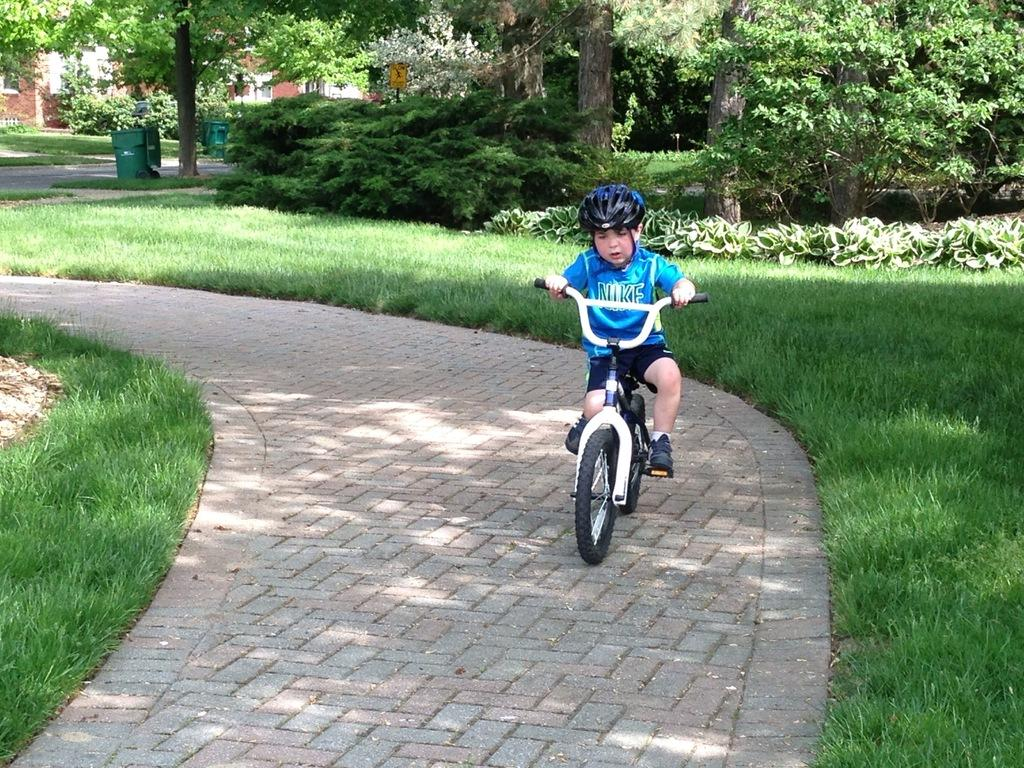What is the kid doing in the image? The kid is riding a bicycle in the image. What type of terrain is visible in the image? There is grass in the image, which suggests a grassy or park-like setting. What other vegetation can be seen in the image? There are plants, trees, and a board in the image. What objects are present for waste disposal? There are bins in the image. What type of structure is visible in the background? There is a house in the image. What color is the kid's nose in the image? There is no information about the kid's nose in the image, so we cannot determine its color. --- Facts: 1. There is a car in the image. 2. The car is red. 3. There are people in the car. 4. The car has four wheels. 5. The car has a license plate. Absurd Topics: parrot, ocean, dance Conversation: What is the main subject of the image? The main subject of the image is a car. What color is the car? The car is red. Are there any passengers in the car? Yes, there are people in the car. How many wheels does the car have? The car has four wheels. Is there any identifying information on the car? Yes, the car has a license plate. Reasoning: Let's think step by step in order to produce the conversation. We start by identifying the main subject in the image, which is the car. Then, we expand the conversation to include other details about the car, such as its color, the presence of passengers, the number of wheels, and the license plate. Each question is designed to elicit a specific detail about the image that is known from the provided facts. Absurd Question/Answer: Can you see a parrot swimming in the ocean in the image? No, there is no parrot or ocean present in the image. 